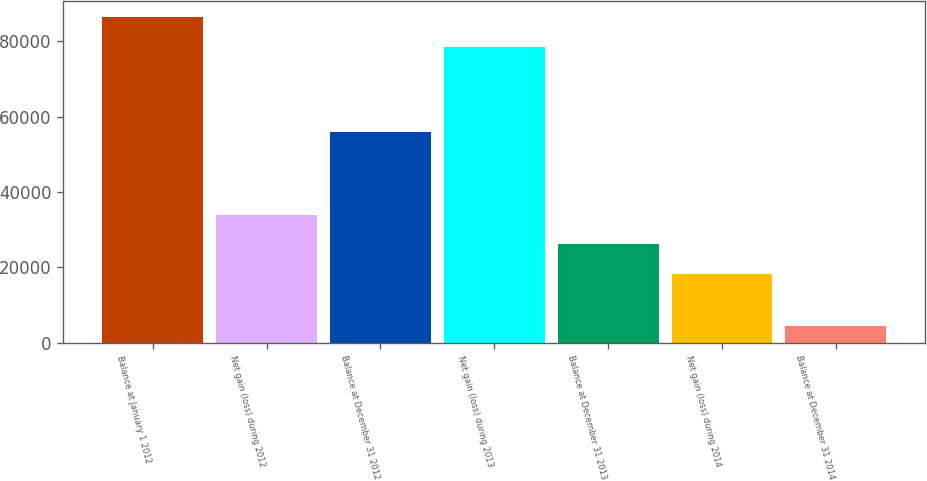Convert chart. <chart><loc_0><loc_0><loc_500><loc_500><bar_chart><fcel>Balance at January 1 2012<fcel>Net gain (loss) during 2012<fcel>Balance at December 31 2012<fcel>Net gain (loss) during 2013<fcel>Balance at December 31 2013<fcel>Net gain (loss) during 2014<fcel>Balance at December 31 2014<nl><fcel>86373.1<fcel>34016.2<fcel>55790<fcel>78422<fcel>26065.1<fcel>18114<fcel>4518<nl></chart> 